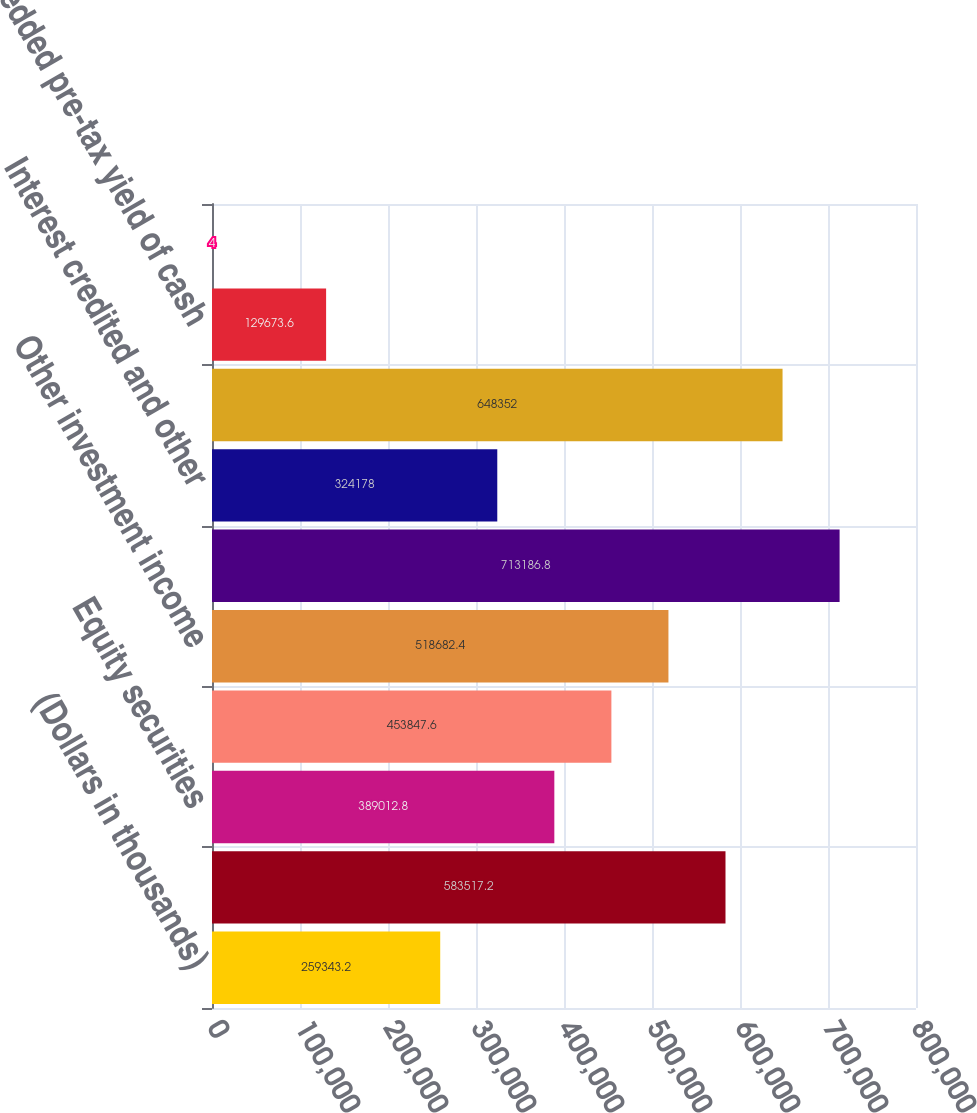Convert chart to OTSL. <chart><loc_0><loc_0><loc_500><loc_500><bar_chart><fcel>(Dollars in thousands)<fcel>Fixed maturities<fcel>Equity securities<fcel>Short-term investments<fcel>Other investment income<fcel>Total gross investment income<fcel>Interest credited and other<fcel>Total net investment income<fcel>Imbedded pre-tax yield of cash<fcel>Imbedded after-tax yield of<nl><fcel>259343<fcel>583517<fcel>389013<fcel>453848<fcel>518682<fcel>713187<fcel>324178<fcel>648352<fcel>129674<fcel>4<nl></chart> 